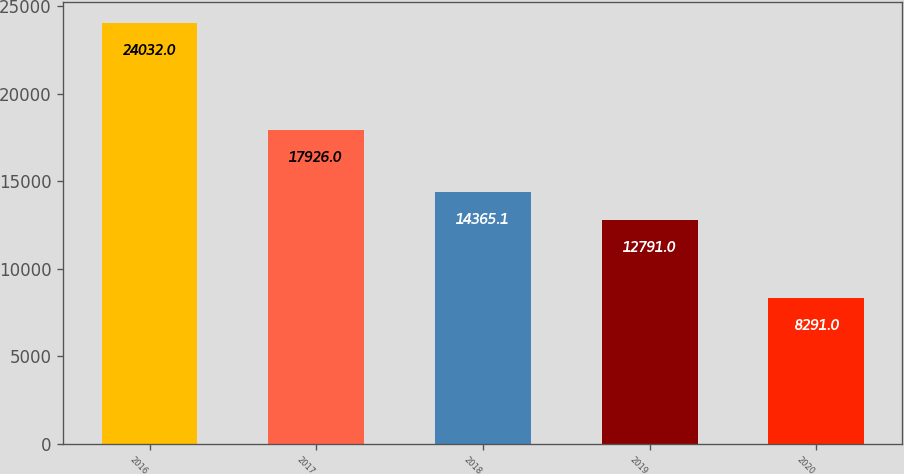Convert chart. <chart><loc_0><loc_0><loc_500><loc_500><bar_chart><fcel>2016<fcel>2017<fcel>2018<fcel>2019<fcel>2020<nl><fcel>24032<fcel>17926<fcel>14365.1<fcel>12791<fcel>8291<nl></chart> 